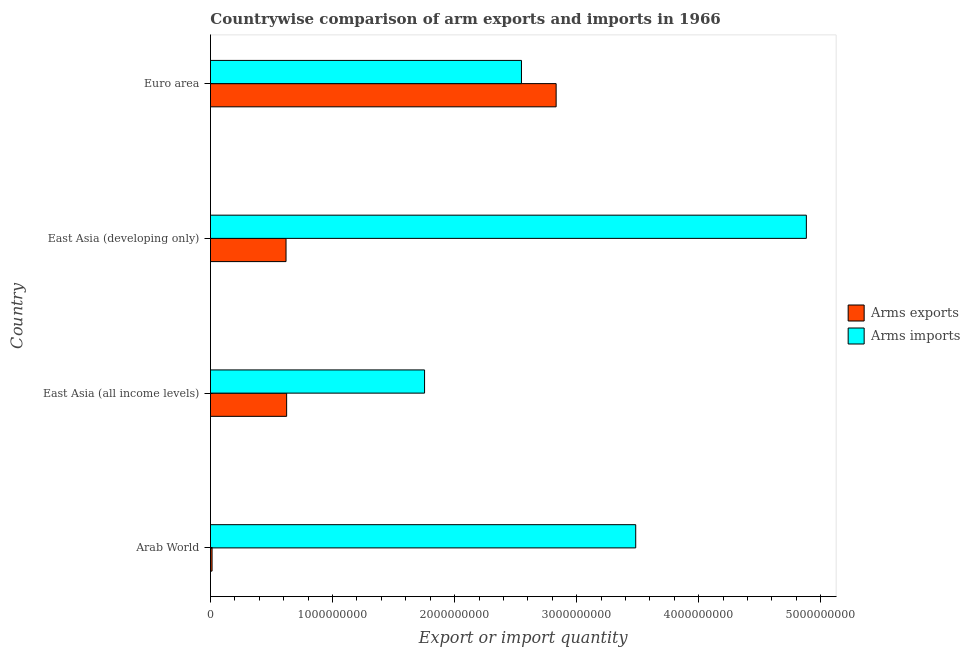How many groups of bars are there?
Provide a succinct answer. 4. Are the number of bars per tick equal to the number of legend labels?
Give a very brief answer. Yes. How many bars are there on the 1st tick from the top?
Ensure brevity in your answer.  2. How many bars are there on the 1st tick from the bottom?
Your answer should be compact. 2. What is the arms imports in Euro area?
Provide a succinct answer. 2.55e+09. Across all countries, what is the maximum arms exports?
Provide a succinct answer. 2.83e+09. Across all countries, what is the minimum arms exports?
Your answer should be very brief. 1.30e+07. In which country was the arms exports minimum?
Make the answer very short. Arab World. What is the total arms exports in the graph?
Your answer should be very brief. 4.09e+09. What is the difference between the arms imports in East Asia (developing only) and that in Euro area?
Keep it short and to the point. 2.33e+09. What is the difference between the arms exports in Euro area and the arms imports in East Asia (all income levels)?
Ensure brevity in your answer.  1.08e+09. What is the average arms exports per country?
Your response must be concise. 1.02e+09. What is the difference between the arms imports and arms exports in East Asia (developing only)?
Provide a short and direct response. 4.26e+09. What is the ratio of the arms imports in East Asia (all income levels) to that in East Asia (developing only)?
Your answer should be compact. 0.36. Is the arms exports in Arab World less than that in East Asia (all income levels)?
Give a very brief answer. Yes. Is the difference between the arms imports in East Asia (all income levels) and Euro area greater than the difference between the arms exports in East Asia (all income levels) and Euro area?
Provide a succinct answer. Yes. What is the difference between the highest and the second highest arms imports?
Offer a very short reply. 1.40e+09. What is the difference between the highest and the lowest arms exports?
Offer a very short reply. 2.82e+09. In how many countries, is the arms imports greater than the average arms imports taken over all countries?
Keep it short and to the point. 2. What does the 2nd bar from the top in Arab World represents?
Ensure brevity in your answer.  Arms exports. What does the 2nd bar from the bottom in Euro area represents?
Your answer should be compact. Arms imports. How many bars are there?
Your answer should be very brief. 8. Are all the bars in the graph horizontal?
Your answer should be compact. Yes. How many countries are there in the graph?
Offer a terse response. 4. Are the values on the major ticks of X-axis written in scientific E-notation?
Offer a terse response. No. How many legend labels are there?
Your answer should be compact. 2. How are the legend labels stacked?
Provide a succinct answer. Vertical. What is the title of the graph?
Keep it short and to the point. Countrywise comparison of arm exports and imports in 1966. Does "Transport services" appear as one of the legend labels in the graph?
Make the answer very short. No. What is the label or title of the X-axis?
Provide a succinct answer. Export or import quantity. What is the label or title of the Y-axis?
Make the answer very short. Country. What is the Export or import quantity of Arms exports in Arab World?
Provide a short and direct response. 1.30e+07. What is the Export or import quantity of Arms imports in Arab World?
Offer a terse response. 3.48e+09. What is the Export or import quantity in Arms exports in East Asia (all income levels)?
Offer a terse response. 6.24e+08. What is the Export or import quantity in Arms imports in East Asia (all income levels)?
Your response must be concise. 1.75e+09. What is the Export or import quantity of Arms exports in East Asia (developing only)?
Give a very brief answer. 6.19e+08. What is the Export or import quantity in Arms imports in East Asia (developing only)?
Offer a very short reply. 4.88e+09. What is the Export or import quantity in Arms exports in Euro area?
Your answer should be very brief. 2.83e+09. What is the Export or import quantity in Arms imports in Euro area?
Provide a succinct answer. 2.55e+09. Across all countries, what is the maximum Export or import quantity in Arms exports?
Offer a terse response. 2.83e+09. Across all countries, what is the maximum Export or import quantity of Arms imports?
Your answer should be compact. 4.88e+09. Across all countries, what is the minimum Export or import quantity of Arms exports?
Provide a short and direct response. 1.30e+07. Across all countries, what is the minimum Export or import quantity of Arms imports?
Your answer should be very brief. 1.75e+09. What is the total Export or import quantity of Arms exports in the graph?
Your answer should be compact. 4.09e+09. What is the total Export or import quantity in Arms imports in the graph?
Offer a terse response. 1.27e+1. What is the difference between the Export or import quantity of Arms exports in Arab World and that in East Asia (all income levels)?
Keep it short and to the point. -6.11e+08. What is the difference between the Export or import quantity of Arms imports in Arab World and that in East Asia (all income levels)?
Provide a short and direct response. 1.73e+09. What is the difference between the Export or import quantity in Arms exports in Arab World and that in East Asia (developing only)?
Your response must be concise. -6.06e+08. What is the difference between the Export or import quantity in Arms imports in Arab World and that in East Asia (developing only)?
Offer a terse response. -1.40e+09. What is the difference between the Export or import quantity in Arms exports in Arab World and that in Euro area?
Keep it short and to the point. -2.82e+09. What is the difference between the Export or import quantity of Arms imports in Arab World and that in Euro area?
Provide a succinct answer. 9.36e+08. What is the difference between the Export or import quantity in Arms exports in East Asia (all income levels) and that in East Asia (developing only)?
Make the answer very short. 5.00e+06. What is the difference between the Export or import quantity of Arms imports in East Asia (all income levels) and that in East Asia (developing only)?
Offer a terse response. -3.13e+09. What is the difference between the Export or import quantity of Arms exports in East Asia (all income levels) and that in Euro area?
Give a very brief answer. -2.21e+09. What is the difference between the Export or import quantity of Arms imports in East Asia (all income levels) and that in Euro area?
Give a very brief answer. -7.94e+08. What is the difference between the Export or import quantity of Arms exports in East Asia (developing only) and that in Euro area?
Offer a very short reply. -2.21e+09. What is the difference between the Export or import quantity of Arms imports in East Asia (developing only) and that in Euro area?
Provide a short and direct response. 2.33e+09. What is the difference between the Export or import quantity in Arms exports in Arab World and the Export or import quantity in Arms imports in East Asia (all income levels)?
Offer a very short reply. -1.74e+09. What is the difference between the Export or import quantity in Arms exports in Arab World and the Export or import quantity in Arms imports in East Asia (developing only)?
Give a very brief answer. -4.87e+09. What is the difference between the Export or import quantity of Arms exports in Arab World and the Export or import quantity of Arms imports in Euro area?
Your answer should be compact. -2.54e+09. What is the difference between the Export or import quantity of Arms exports in East Asia (all income levels) and the Export or import quantity of Arms imports in East Asia (developing only)?
Provide a short and direct response. -4.26e+09. What is the difference between the Export or import quantity of Arms exports in East Asia (all income levels) and the Export or import quantity of Arms imports in Euro area?
Provide a succinct answer. -1.92e+09. What is the difference between the Export or import quantity of Arms exports in East Asia (developing only) and the Export or import quantity of Arms imports in Euro area?
Offer a terse response. -1.93e+09. What is the average Export or import quantity in Arms exports per country?
Give a very brief answer. 1.02e+09. What is the average Export or import quantity in Arms imports per country?
Offer a terse response. 3.17e+09. What is the difference between the Export or import quantity in Arms exports and Export or import quantity in Arms imports in Arab World?
Keep it short and to the point. -3.47e+09. What is the difference between the Export or import quantity of Arms exports and Export or import quantity of Arms imports in East Asia (all income levels)?
Make the answer very short. -1.13e+09. What is the difference between the Export or import quantity of Arms exports and Export or import quantity of Arms imports in East Asia (developing only)?
Ensure brevity in your answer.  -4.26e+09. What is the difference between the Export or import quantity in Arms exports and Export or import quantity in Arms imports in Euro area?
Make the answer very short. 2.84e+08. What is the ratio of the Export or import quantity in Arms exports in Arab World to that in East Asia (all income levels)?
Offer a very short reply. 0.02. What is the ratio of the Export or import quantity in Arms imports in Arab World to that in East Asia (all income levels)?
Provide a short and direct response. 1.99. What is the ratio of the Export or import quantity in Arms exports in Arab World to that in East Asia (developing only)?
Make the answer very short. 0.02. What is the ratio of the Export or import quantity of Arms imports in Arab World to that in East Asia (developing only)?
Ensure brevity in your answer.  0.71. What is the ratio of the Export or import quantity in Arms exports in Arab World to that in Euro area?
Give a very brief answer. 0. What is the ratio of the Export or import quantity of Arms imports in Arab World to that in Euro area?
Offer a very short reply. 1.37. What is the ratio of the Export or import quantity of Arms exports in East Asia (all income levels) to that in East Asia (developing only)?
Offer a terse response. 1.01. What is the ratio of the Export or import quantity of Arms imports in East Asia (all income levels) to that in East Asia (developing only)?
Ensure brevity in your answer.  0.36. What is the ratio of the Export or import quantity in Arms exports in East Asia (all income levels) to that in Euro area?
Your response must be concise. 0.22. What is the ratio of the Export or import quantity of Arms imports in East Asia (all income levels) to that in Euro area?
Your response must be concise. 0.69. What is the ratio of the Export or import quantity in Arms exports in East Asia (developing only) to that in Euro area?
Give a very brief answer. 0.22. What is the ratio of the Export or import quantity in Arms imports in East Asia (developing only) to that in Euro area?
Keep it short and to the point. 1.92. What is the difference between the highest and the second highest Export or import quantity in Arms exports?
Provide a short and direct response. 2.21e+09. What is the difference between the highest and the second highest Export or import quantity of Arms imports?
Offer a terse response. 1.40e+09. What is the difference between the highest and the lowest Export or import quantity in Arms exports?
Offer a very short reply. 2.82e+09. What is the difference between the highest and the lowest Export or import quantity in Arms imports?
Your response must be concise. 3.13e+09. 